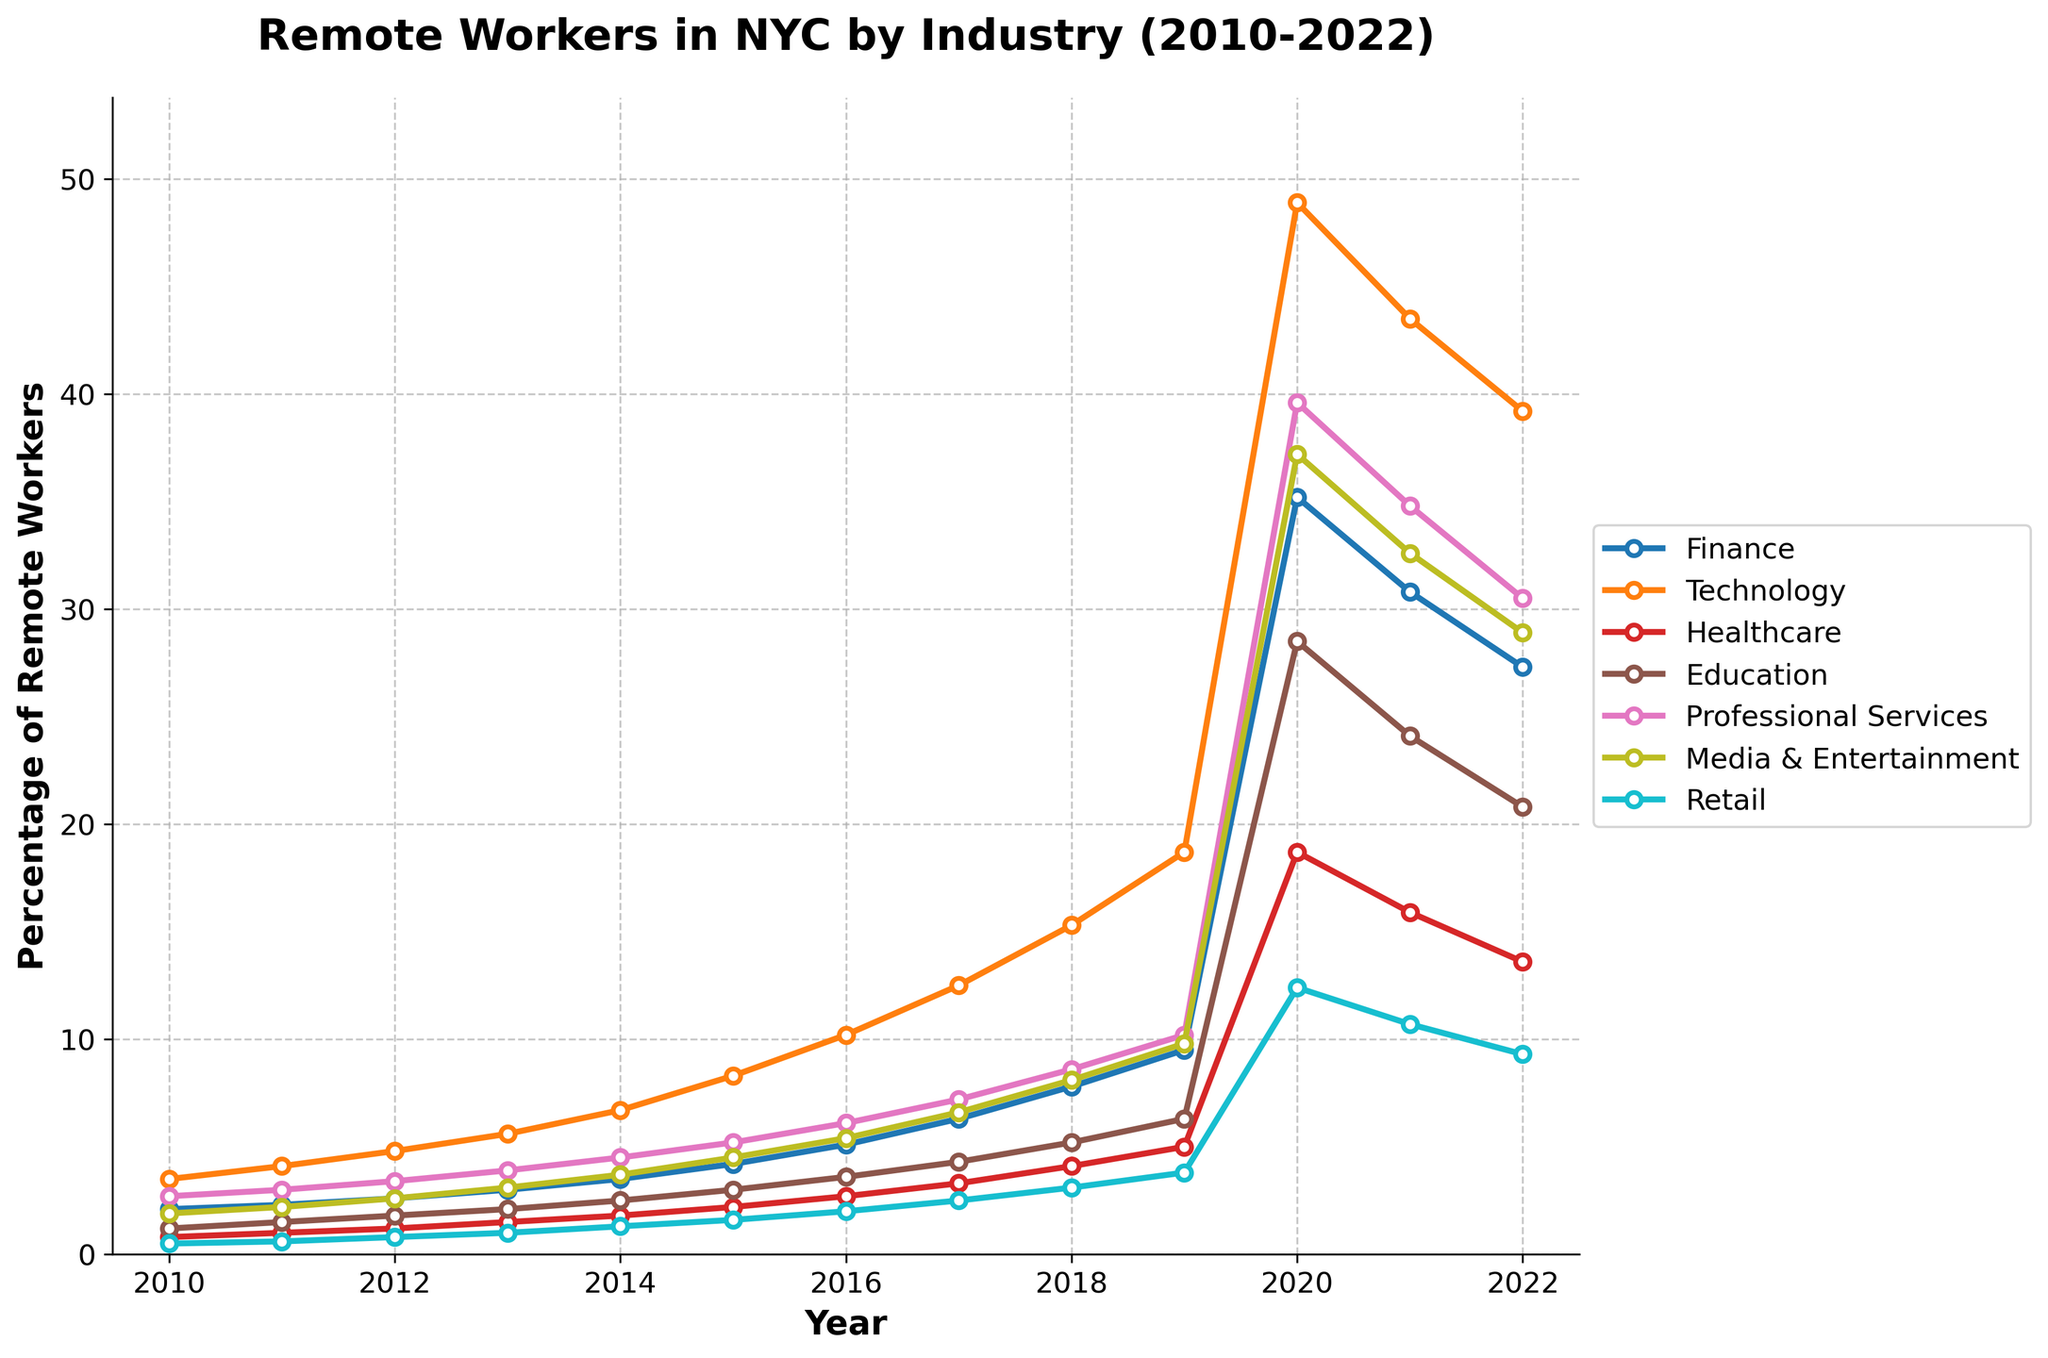What's the general trend in the percentage of remote workers in New York City's Technology sector from 2010 to 2022? The plot shows an upward trend in the Technology sector, starting at 3.5% in 2010 and reaching 48.9% in 2020 before slightly declining to 39.2% in 2022. This indicates a significant increase over the years.
Answer: Upward trend Which industry saw the highest percentage increase in remote workers during the year 2020? By observing the individual lines in the plot for the year 2020, the Technology sector had the highest percentage at 48.9%, which is the tallest point amongst all industry lines in that year.
Answer: Technology How did the percentage of remote workers in the Healthcare sector change from 2019 to 2021? The Healthcare sector increased from 5.0% in 2019 to 18.7% in 2020, then decreased to 15.9% in 2021, indicating a rise followed by a slight reduction.
Answer: Increased, then decreased Between 2010 and 2022, which two industries had the closest percentage of remote workers in the year 2017? Comparing the plotted lines for 2017, the percentages for Media & Entertainment (6.6%) and Technology (12.5%) are quite distinct. However, Finance (6.3%) and Media & Entertainment are closest to each other.
Answer: Finance and Media & Entertainment What is the average percentage of remote workers in the Professional Services sector from 2020 to 2022? The percentages for 2020, 2021, and 2022 in Professional Services are 39.6%, 34.8%, and 30.5%, respectively. The average is calculated as (39.6 + 34.8 + 30.5) / 3 = 34.97.
Answer: 34.97 Which industry experienced the smallest change in the percentage of remote workers from 2010 to 2016? By analyzing the vertical distance between 2010 and 2016 for each industry line, Retail shows the smallest change, increasing from 0.5% to 2.0%.
Answer: Retail In which year did the Education sector see the fastest increase in remote workers? The plot displays a significant jump in the Education line between 2019 (6.3%) and 2020 (28.5%), indicating the fastest increase in that year.
Answer: 2020 Which sector had the highest percentage of remote workers in 2022 and what was the percentage? Observing the final (2022) data points of each line, the Technology sector is the highest at 39.2%.
Answer: Technology, 39.2% Was there any industry that did not reach at least 10% remote workers by 2022? By examining the year 2022, the Retail industry did not reach 10%, only going up to 9.3%.
Answer: Retail 